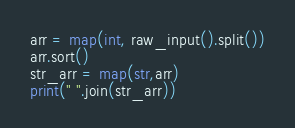Convert code to text. <code><loc_0><loc_0><loc_500><loc_500><_Python_>arr = map(int, raw_input().split())
arr.sort()
str_arr = map(str,arr)
print(" ".join(str_arr))</code> 